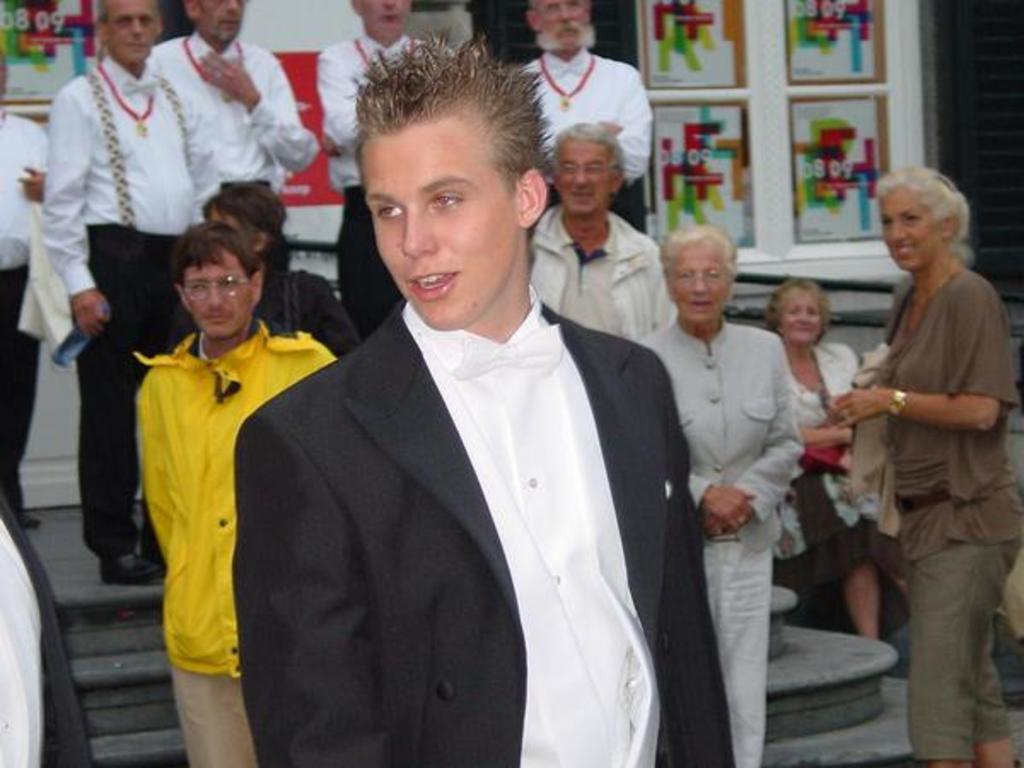Who or what can be seen in the image? There are people in the image. What architectural feature is present in the image? There are steps in the image. What can be seen on the walls in the background of the image? There are posters on walls in the background of the image. What type of bone can be seen in the image? There is no bone present in the image. What emotion do the people in the image seem to be experiencing? The provided facts do not give information about the emotions of the people in the image. 